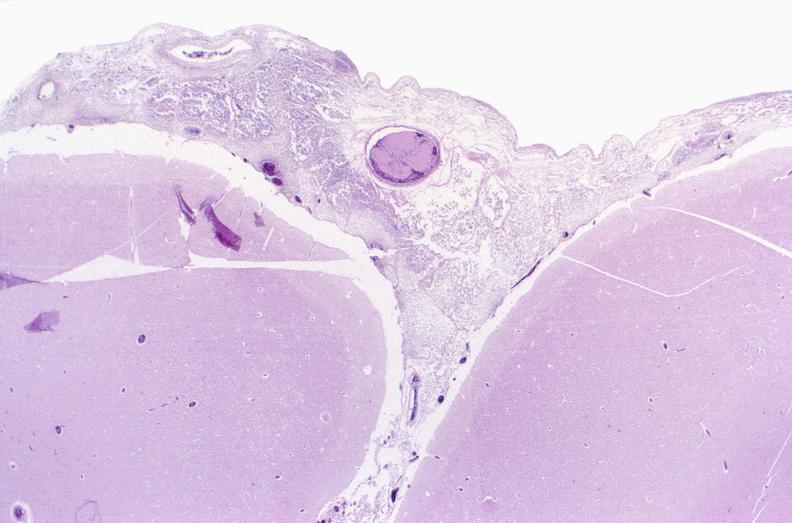does foot show bacterial meningitis?
Answer the question using a single word or phrase. No 